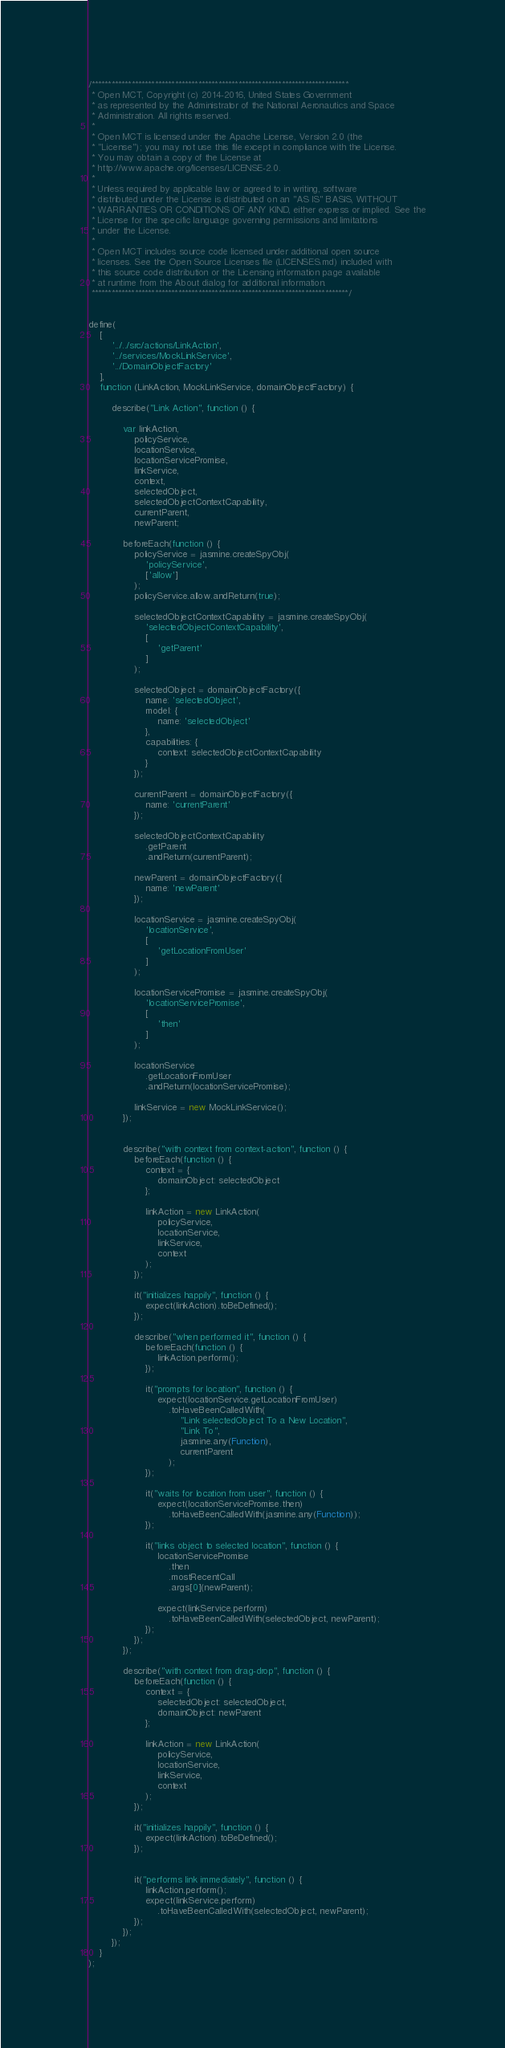<code> <loc_0><loc_0><loc_500><loc_500><_JavaScript_>/*****************************************************************************
 * Open MCT, Copyright (c) 2014-2016, United States Government
 * as represented by the Administrator of the National Aeronautics and Space
 * Administration. All rights reserved.
 *
 * Open MCT is licensed under the Apache License, Version 2.0 (the
 * "License"); you may not use this file except in compliance with the License.
 * You may obtain a copy of the License at
 * http://www.apache.org/licenses/LICENSE-2.0.
 *
 * Unless required by applicable law or agreed to in writing, software
 * distributed under the License is distributed on an "AS IS" BASIS, WITHOUT
 * WARRANTIES OR CONDITIONS OF ANY KIND, either express or implied. See the
 * License for the specific language governing permissions and limitations
 * under the License.
 *
 * Open MCT includes source code licensed under additional open source
 * licenses. See the Open Source Licenses file (LICENSES.md) included with
 * this source code distribution or the Licensing information page available
 * at runtime from the About dialog for additional information.
 *****************************************************************************/


define(
    [
        '../../src/actions/LinkAction',
        '../services/MockLinkService',
        '../DomainObjectFactory'
    ],
    function (LinkAction, MockLinkService, domainObjectFactory) {

        describe("Link Action", function () {

            var linkAction,
                policyService,
                locationService,
                locationServicePromise,
                linkService,
                context,
                selectedObject,
                selectedObjectContextCapability,
                currentParent,
                newParent;

            beforeEach(function () {
                policyService = jasmine.createSpyObj(
                    'policyService',
                    ['allow']
                );
                policyService.allow.andReturn(true);

                selectedObjectContextCapability = jasmine.createSpyObj(
                    'selectedObjectContextCapability',
                    [
                        'getParent'
                    ]
                );

                selectedObject = domainObjectFactory({
                    name: 'selectedObject',
                    model: {
                        name: 'selectedObject'
                    },
                    capabilities: {
                        context: selectedObjectContextCapability
                    }
                });

                currentParent = domainObjectFactory({
                    name: 'currentParent'
                });

                selectedObjectContextCapability
                    .getParent
                    .andReturn(currentParent);

                newParent = domainObjectFactory({
                    name: 'newParent'
                });

                locationService = jasmine.createSpyObj(
                    'locationService',
                    [
                        'getLocationFromUser'
                    ]
                );

                locationServicePromise = jasmine.createSpyObj(
                    'locationServicePromise',
                    [
                        'then'
                    ]
                );

                locationService
                    .getLocationFromUser
                    .andReturn(locationServicePromise);

                linkService = new MockLinkService();
            });


            describe("with context from context-action", function () {
                beforeEach(function () {
                    context = {
                        domainObject: selectedObject
                    };

                    linkAction = new LinkAction(
                        policyService,
                        locationService,
                        linkService,
                        context
                    );
                });

                it("initializes happily", function () {
                    expect(linkAction).toBeDefined();
                });

                describe("when performed it", function () {
                    beforeEach(function () {
                        linkAction.perform();
                    });

                    it("prompts for location", function () {
                        expect(locationService.getLocationFromUser)
                            .toHaveBeenCalledWith(
                                "Link selectedObject To a New Location",
                                "Link To",
                                jasmine.any(Function),
                                currentParent
                            );
                    });

                    it("waits for location from user", function () {
                        expect(locationServicePromise.then)
                            .toHaveBeenCalledWith(jasmine.any(Function));
                    });

                    it("links object to selected location", function () {
                        locationServicePromise
                            .then
                            .mostRecentCall
                            .args[0](newParent);

                        expect(linkService.perform)
                            .toHaveBeenCalledWith(selectedObject, newParent);
                    });
                });
            });

            describe("with context from drag-drop", function () {
                beforeEach(function () {
                    context = {
                        selectedObject: selectedObject,
                        domainObject: newParent
                    };

                    linkAction = new LinkAction(
                        policyService,
                        locationService,
                        linkService,
                        context
                    );
                });

                it("initializes happily", function () {
                    expect(linkAction).toBeDefined();
                });


                it("performs link immediately", function () {
                    linkAction.perform();
                    expect(linkService.perform)
                        .toHaveBeenCalledWith(selectedObject, newParent);
                });
            });
        });
    }
);
</code> 